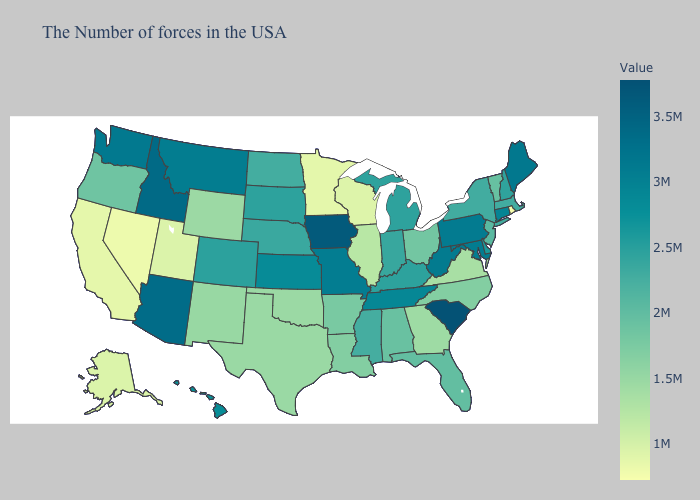Does Kentucky have the lowest value in the USA?
Short answer required. No. Does Virginia have the lowest value in the South?
Short answer required. Yes. Which states have the highest value in the USA?
Answer briefly. South Carolina. Does South Carolina have the highest value in the South?
Quick response, please. Yes. 